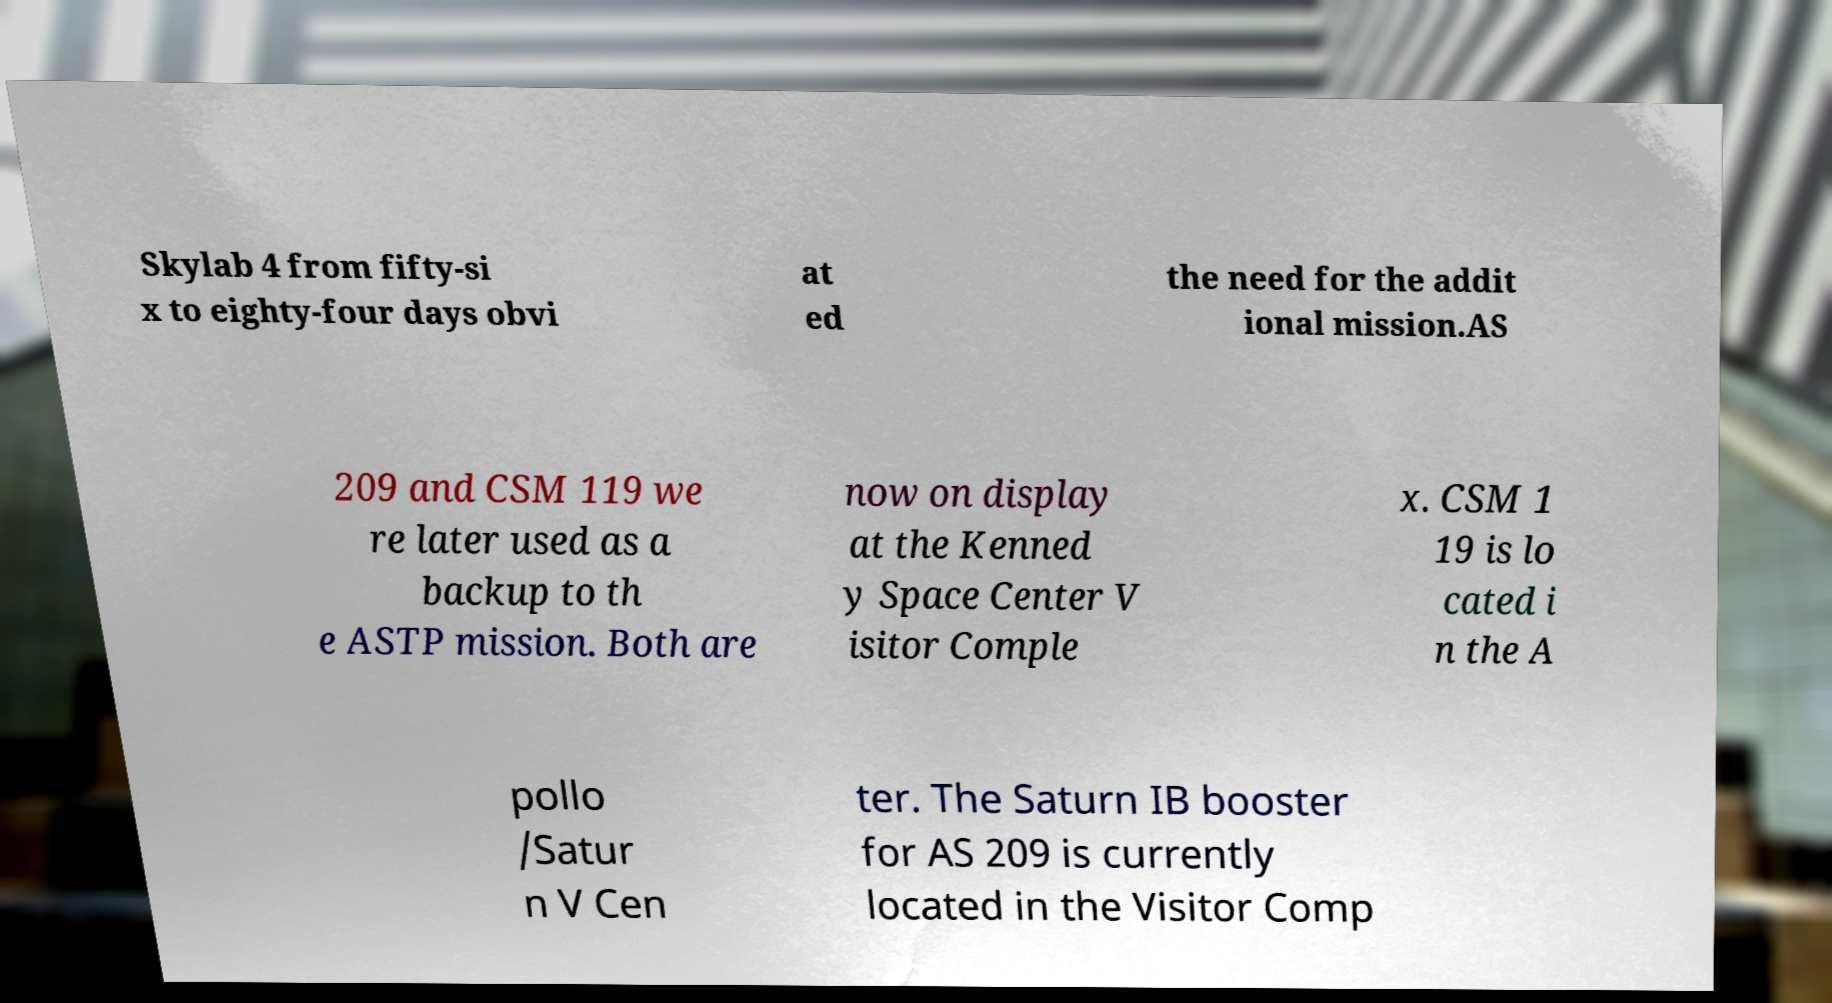What messages or text are displayed in this image? I need them in a readable, typed format. Skylab 4 from fifty-si x to eighty-four days obvi at ed the need for the addit ional mission.AS 209 and CSM 119 we re later used as a backup to th e ASTP mission. Both are now on display at the Kenned y Space Center V isitor Comple x. CSM 1 19 is lo cated i n the A pollo /Satur n V Cen ter. The Saturn IB booster for AS 209 is currently located in the Visitor Comp 